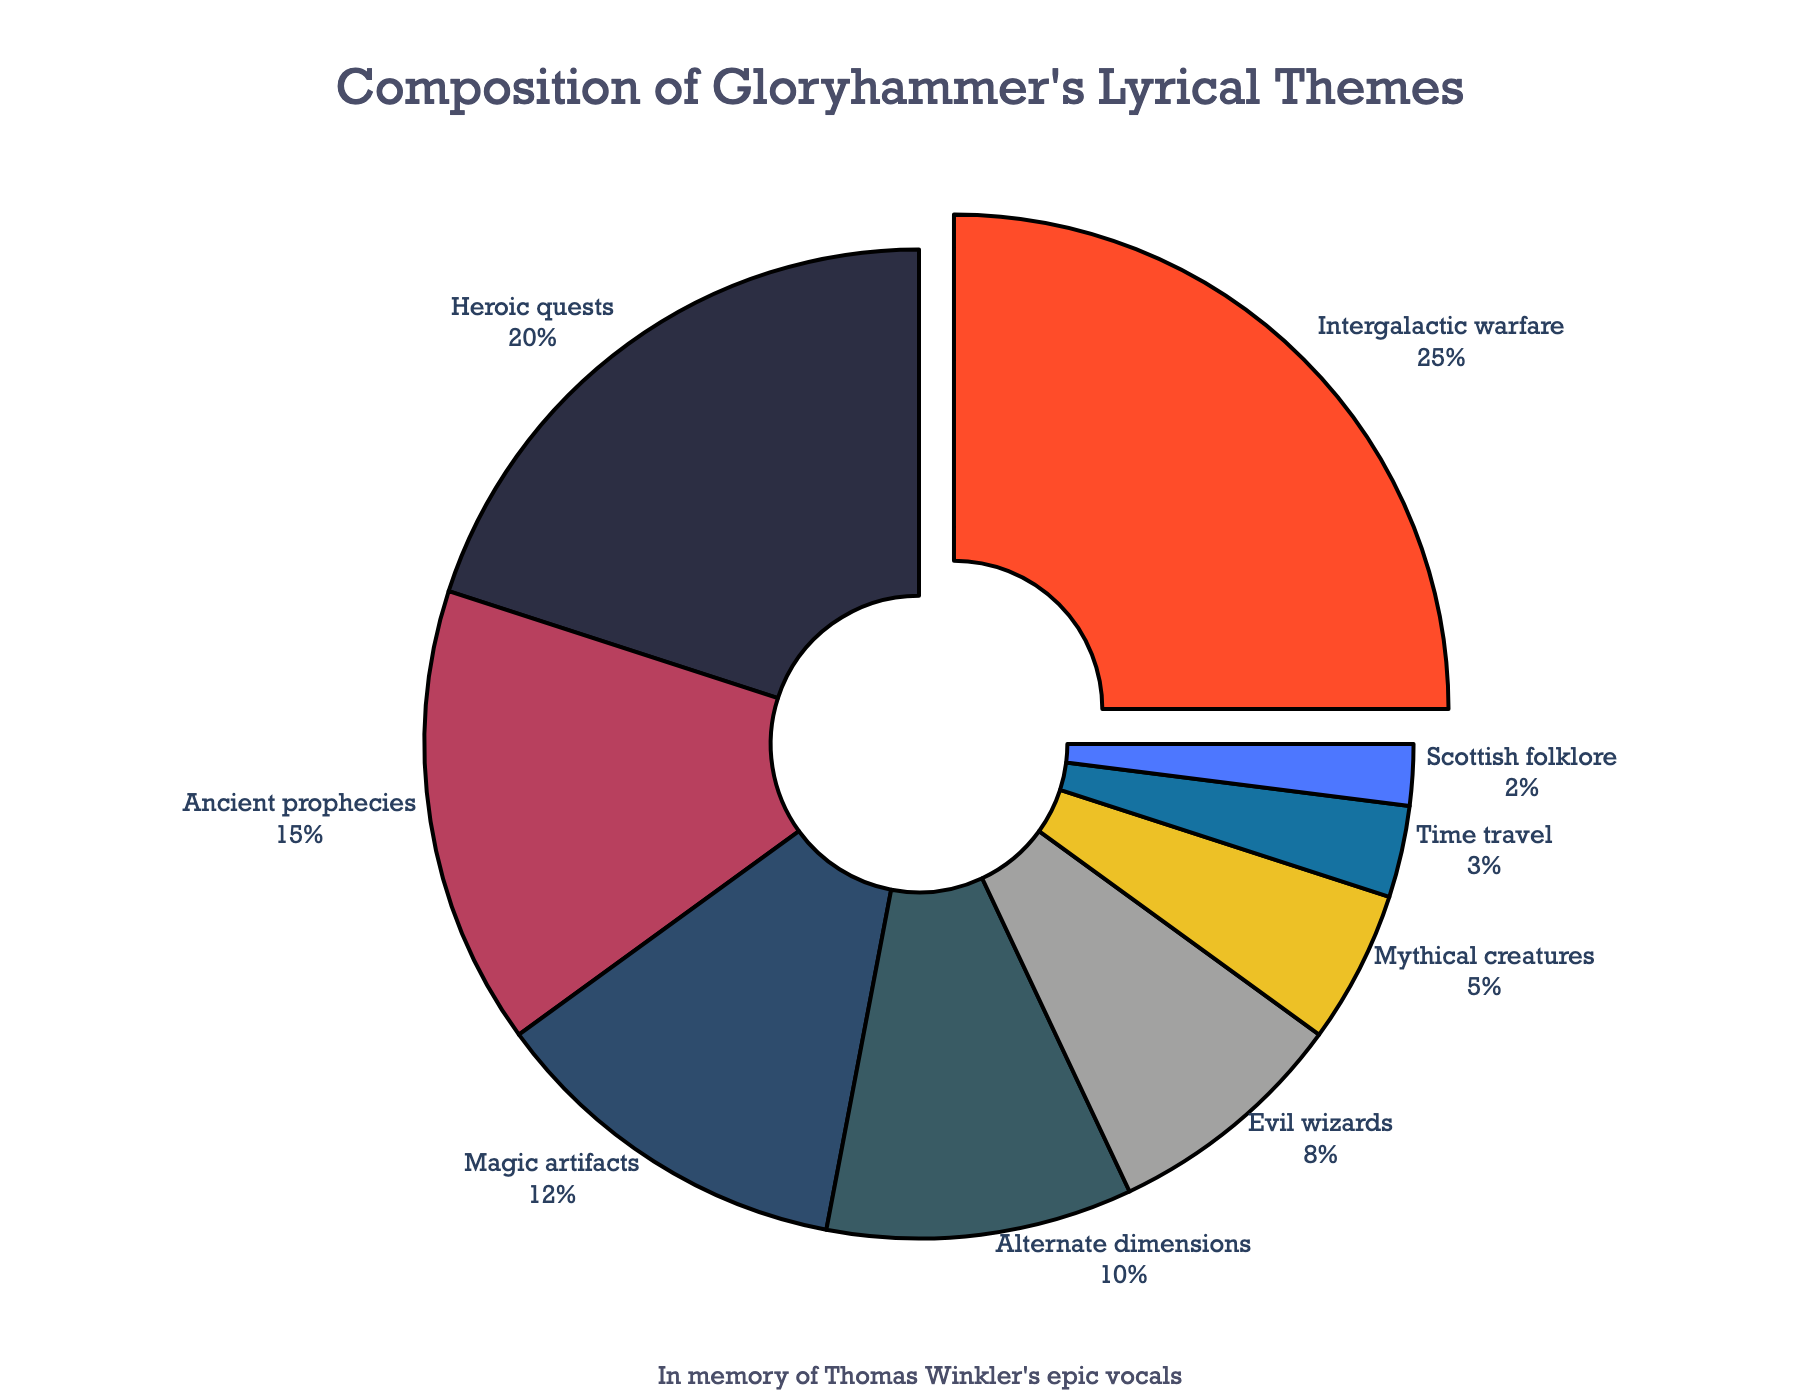What lyrical theme has the highest composition percentage in the plot? By observing the segments in the pie chart and their labeled percentages, we can identify that 'Intergalactic warfare' has the largest segment, representing 25%.
Answer: Intergalactic warfare What is the combined percentage of 'Ancient prophecies' and 'Evil wizards'? The pie chart shows that 'Ancient prophecies' is 15% and 'Evil wizards' is 8%. Adding these two values: 15% + 8% = 23%.
Answer: 23% What fraction of the themes are dedicated to concepts related to 'Scottish folklore' and 'Time travel' combined? The percentage for 'Scottish folklore' is 2% and for 'Time travel' is 3%. Summing these values: 2% + 3% = 5%. Therefore, the fraction is 5%.
Answer: 5% Which is the smallest lyrical theme group, and what is its percentage? By comparing all the segments and their percentages on the pie chart, 'Scottish folklore' is identified as the smallest segment with a percentage of 2%.
Answer: Scottish folklore, 2% How do 'Magic artifacts' and 'Alternate dimensions' compare in terms of their composition percentages? 'Magic artifacts' has a percentage of 12%, while 'Alternate dimensions' has 10%. Therefore, 'Magic artifacts' is greater than 'Alternate dimensions' by 2%.
Answer: Magic artifacts is greater What is the difference between the percentage of 'Heroic quests' and 'Intergalactic warfare'? 'Heroic quests' has a percentage of 20% and 'Intergalactic warfare' has a percentage of 25%. The difference is 25% - 20% = 5%.
Answer: 5% What is the total percentage of themes linked with supernatural elements ('Magic artifacts', 'Evil wizards', and 'Mythical creatures')? By referring to the pie chart, 'Magic artifacts' is 12%, 'Evil wizards' is 8%, and 'Mythical creatures' is 5%. Summing these values: 12% + 8% + 5% = 25%.
Answer: 25% What are the themes represented by red and blue segments, and what are their percentages? In the pie chart, the red segment is labeled 'Intergalactic warfare' with 25%, and the blue segment is labeled 'Magic artifacts' with 12%.
Answer: Intergalactic warfare: 25%, Magic artifacts: 12% Among 'Ancient prophecies', 'Heroic quests', and 'Evil wizards', which theme has the highest visual proportion and what is it? 'Heroic quests' has a percentage of 20%, making it visually larger than 'Ancient prophecies' at 15% and 'Evil wizards' at 8%.
Answer: Heroic quests, 20% If one were to group 'Alternate dimensions', 'Time travel', and 'Mythical creatures', what would be their combined percentage? 'Alternate dimensions' is at 10%, 'Time travel' is 3%, and 'Mythical creatures' is 5%. Their sum is 10% + 3% + 5% = 18%.
Answer: 18% 